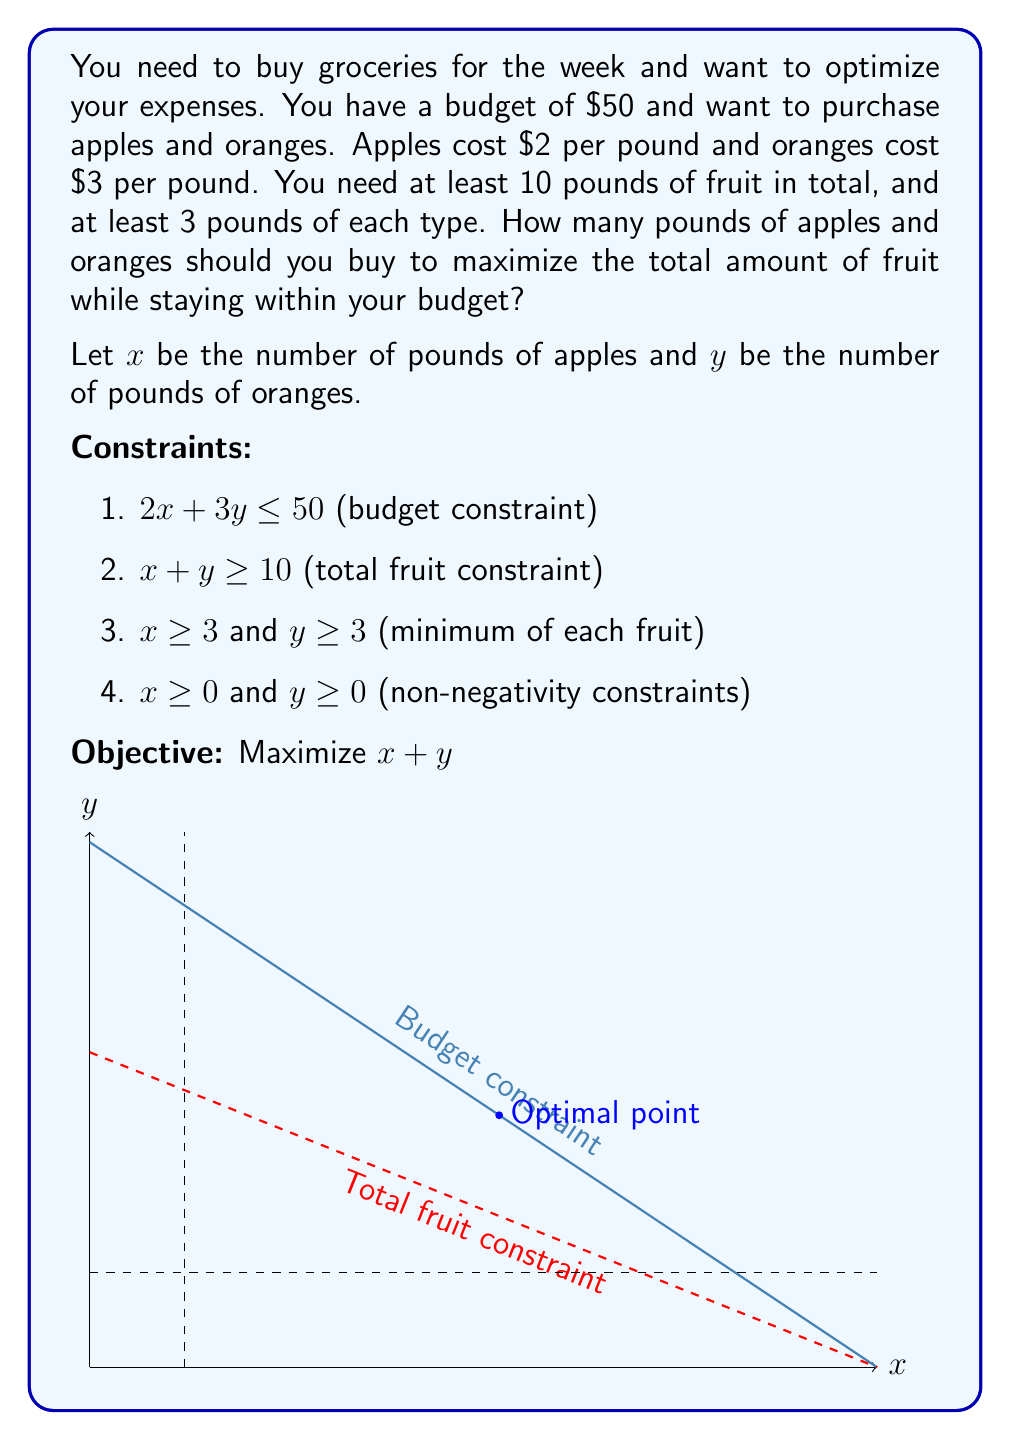Teach me how to tackle this problem. To solve this linear programming problem, we'll follow these steps:

1) First, we identify the feasible region based on the constraints:
   - Budget: $2x + 3y \leq 50$
   - Total fruit: $x + y \geq 10$
   - Minimum apples: $x \geq 3$
   - Minimum oranges: $y \geq 3$

2) The optimal solution will be at one of the corner points of this feasible region. We can find these points by solving the equations of the lines that intersect.

3) The most likely candidates for the optimal solution are:
   a) The intersection of the budget line and the total fruit line:
      $2x + 3y = 50$ and $x + y = 10$
      Solving these simultaneously:
      $x = 13$ and $y = 8$

   b) The intersection of the budget line and the minimum oranges line:
      $2x + 3y = 50$ and $y = 3$
      Solving these:
      $x = 22$ and $y = 3$

4) We need to check if these points satisfy all constraints:
   - Point (13, 8) satisfies all constraints
   - Point (22, 3) satisfies all constraints

5) Now we evaluate our objective function (x + y) at these points:
   - At (13, 8): 13 + 8 = 21
   - At (22, 3): 22 + 3 = 25

6) The point (22, 3) gives us the maximum total amount of fruit (25 pounds) while staying within our budget and satisfying all constraints.

Therefore, you should buy 22 pounds of apples and 3 pounds of oranges.
Answer: 22 pounds of apples, 3 pounds of oranges 